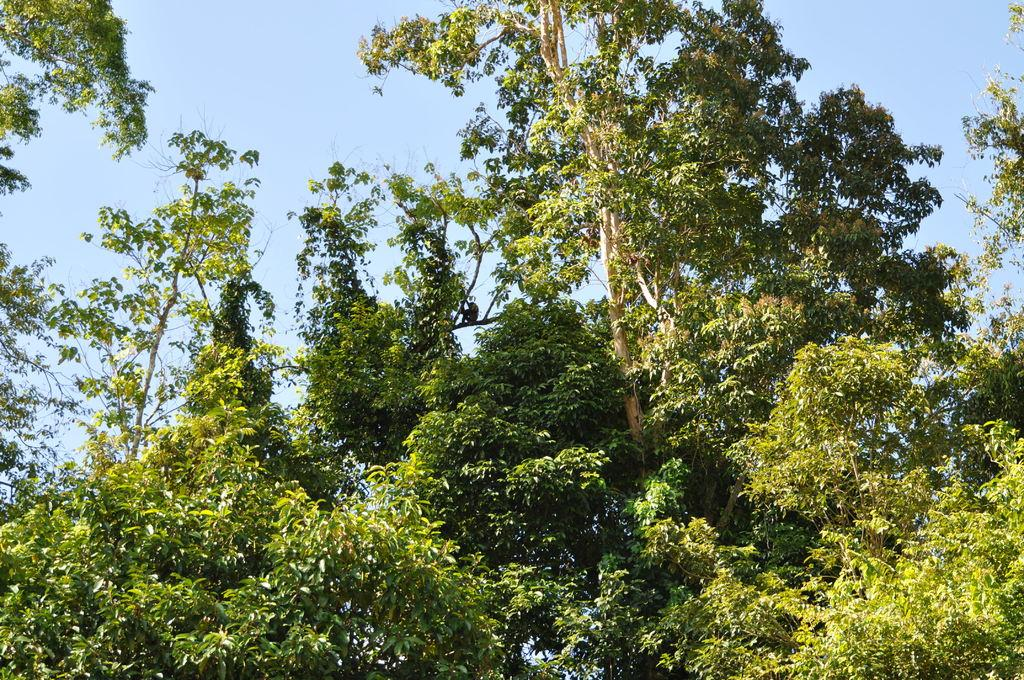What type of vegetation can be seen in the background of the image? There are trees in the background of the image. What part of the natural environment is visible in the background of the image? The sky is visible in the background of the image. What type of pen is being used to draw on the leaves in the image? There are no leaves or pens present in the image. How is the whip being used in the image? There is no whip present in the image. 